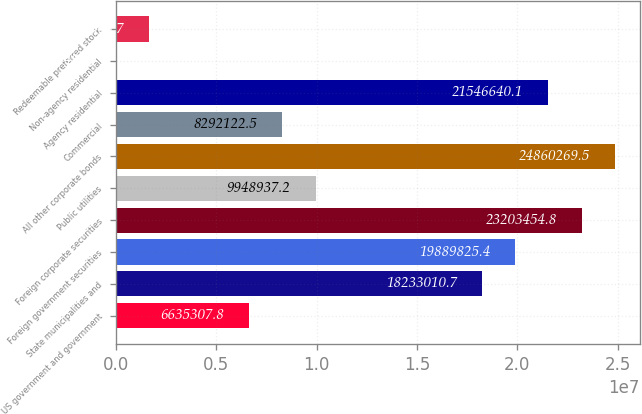Convert chart. <chart><loc_0><loc_0><loc_500><loc_500><bar_chart><fcel>US government and government<fcel>State municipalities and<fcel>Foreign government securities<fcel>Foreign corporate securities<fcel>Public utilities<fcel>All other corporate bonds<fcel>Commercial<fcel>Agency residential<fcel>Non-agency residential<fcel>Redeemable preferred stock<nl><fcel>6.63531e+06<fcel>1.8233e+07<fcel>1.98898e+07<fcel>2.32035e+07<fcel>9.94894e+06<fcel>2.48603e+07<fcel>8.29212e+06<fcel>2.15466e+07<fcel>8049<fcel>1.66486e+06<nl></chart> 